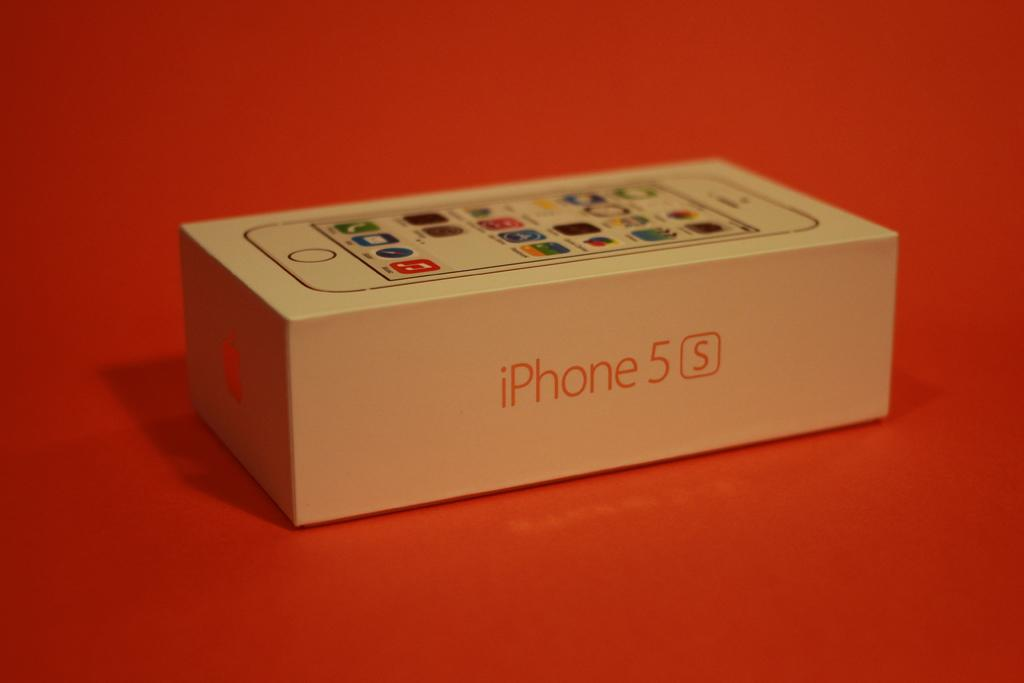<image>
Offer a succinct explanation of the picture presented. the word iPhone is on the white box 